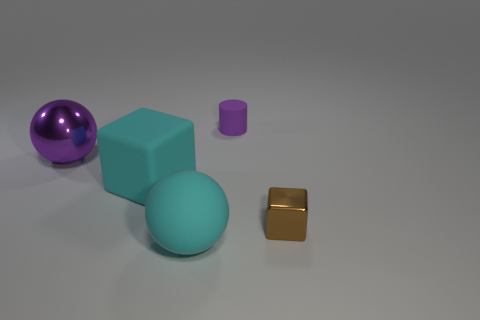There is a large ball that is on the right side of the big metal sphere; is its color the same as the block that is behind the brown thing?
Provide a short and direct response. Yes. There is a big ball that is the same color as the large cube; what material is it?
Your answer should be compact. Rubber. How many objects are either large rubber balls or things left of the tiny purple thing?
Make the answer very short. 3. There is a metallic thing that is right of the purple object that is to the right of the large purple shiny object; what number of tiny purple matte things are in front of it?
Provide a succinct answer. 0. What is the material of the purple sphere that is the same size as the cyan block?
Make the answer very short. Metal. Is there a brown block of the same size as the purple matte object?
Provide a succinct answer. Yes. What color is the small cylinder?
Your answer should be very brief. Purple. What is the color of the cylinder on the left side of the shiny thing right of the tiny purple object?
Your response must be concise. Purple. There is a cyan matte object left of the big sphere that is in front of the metallic object to the right of the purple rubber cylinder; what is its shape?
Your response must be concise. Cube. How many brown cubes are the same material as the cylinder?
Keep it short and to the point. 0. 